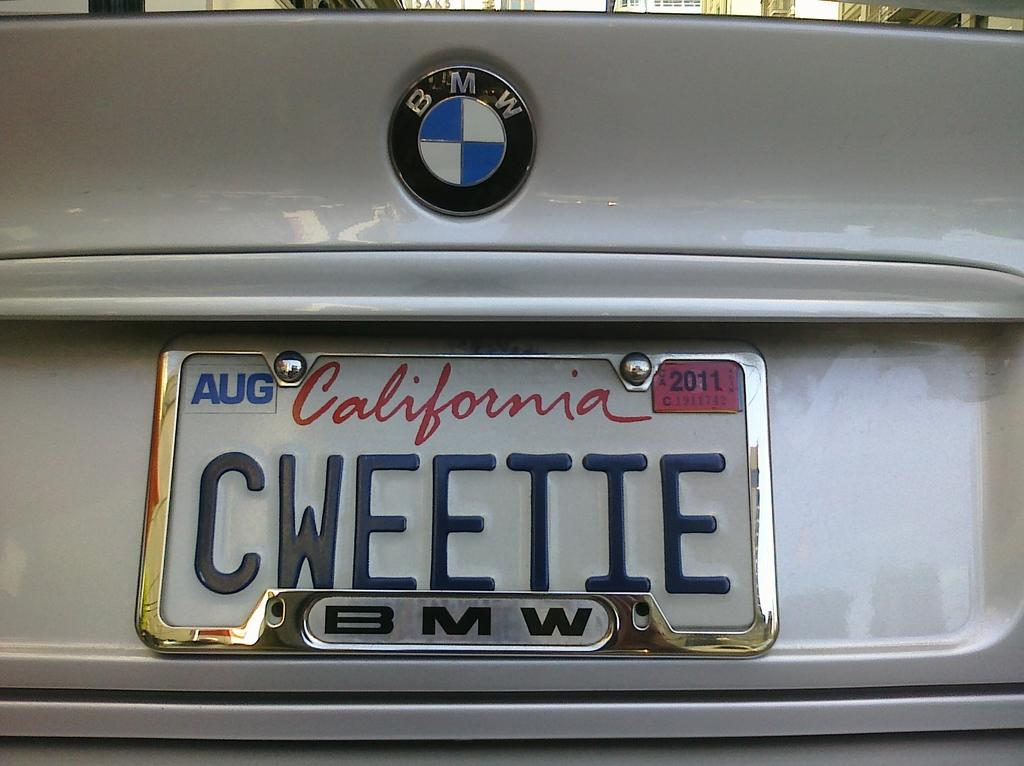<image>
Relay a brief, clear account of the picture shown. A BMW car has California license plate "CWEETIE" on it. 